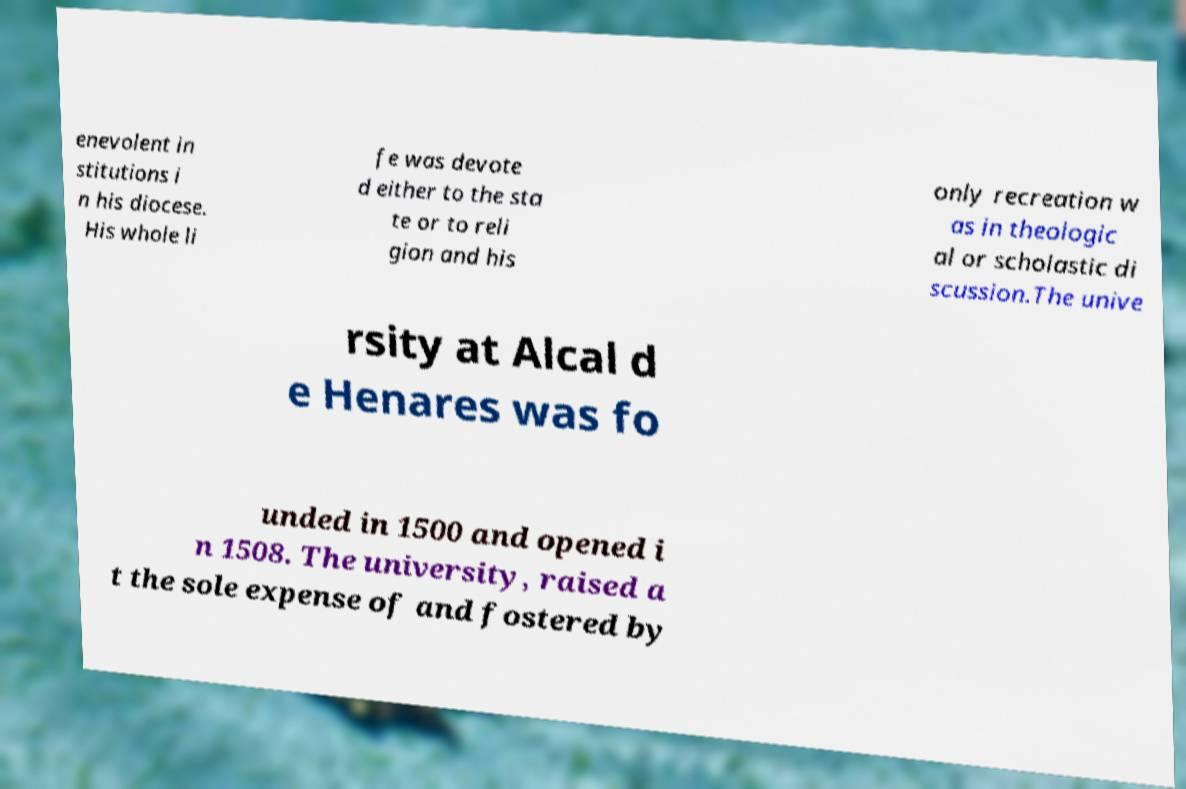Please read and relay the text visible in this image. What does it say? enevolent in stitutions i n his diocese. His whole li fe was devote d either to the sta te or to reli gion and his only recreation w as in theologic al or scholastic di scussion.The unive rsity at Alcal d e Henares was fo unded in 1500 and opened i n 1508. The university, raised a t the sole expense of and fostered by 